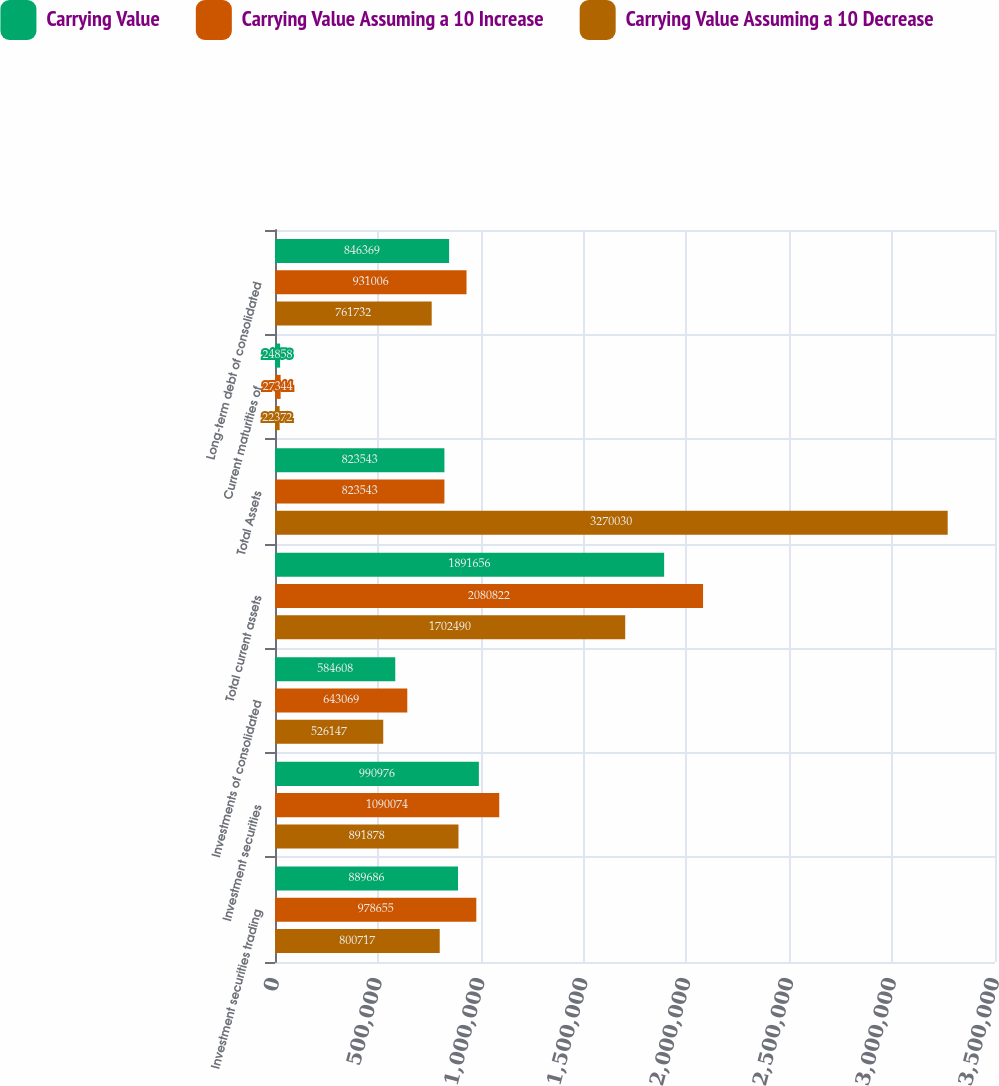Convert chart to OTSL. <chart><loc_0><loc_0><loc_500><loc_500><stacked_bar_chart><ecel><fcel>Investment securities trading<fcel>Investment securities<fcel>Investments of consolidated<fcel>Total current assets<fcel>Total Assets<fcel>Current maturities of<fcel>Long-term debt of consolidated<nl><fcel>Carrying Value<fcel>889686<fcel>990976<fcel>584608<fcel>1.89166e+06<fcel>823543<fcel>24858<fcel>846369<nl><fcel>Carrying Value Assuming a 10 Increase<fcel>978655<fcel>1.09007e+06<fcel>643069<fcel>2.08082e+06<fcel>823543<fcel>27344<fcel>931006<nl><fcel>Carrying Value Assuming a 10 Decrease<fcel>800717<fcel>891878<fcel>526147<fcel>1.70249e+06<fcel>3.27003e+06<fcel>22372<fcel>761732<nl></chart> 